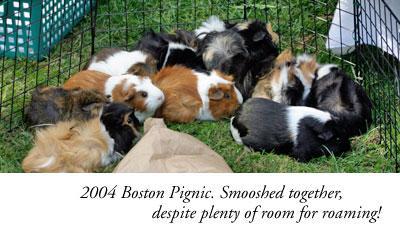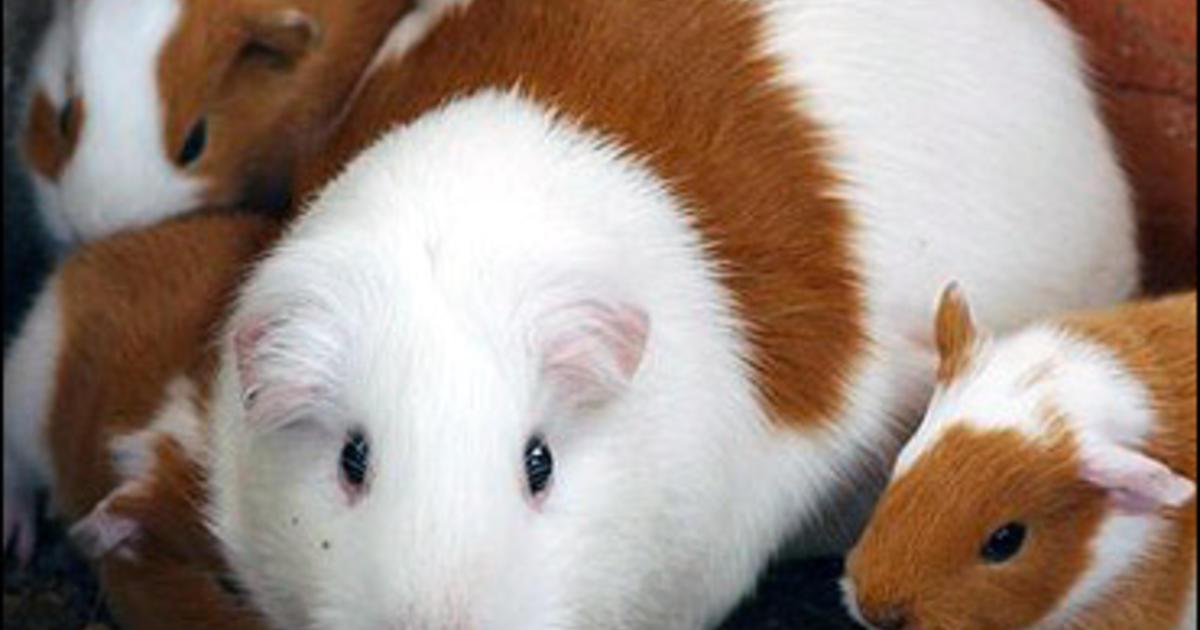The first image is the image on the left, the second image is the image on the right. Examine the images to the left and right. Is the description "An image features at least five guinea pigs on green grass, and each image contains multiple guinea pigs." accurate? Answer yes or no. Yes. The first image is the image on the left, the second image is the image on the right. For the images shown, is this caption "One of the images shows multiple guinea pigs on green grass." true? Answer yes or no. Yes. 